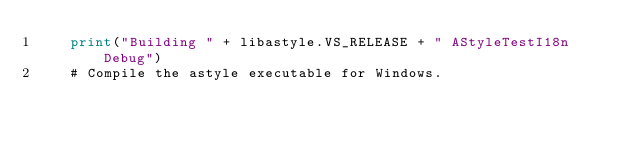<code> <loc_0><loc_0><loc_500><loc_500><_Python_>    print("Building " + libastyle.VS_RELEASE + " AStyleTestI18n Debug")
    # Compile the astyle executable for Windows.</code> 